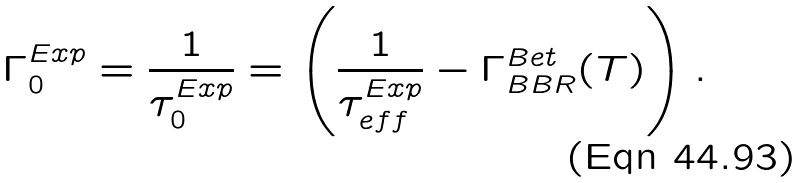Convert formula to latex. <formula><loc_0><loc_0><loc_500><loc_500>\Gamma _ { 0 } ^ { E x p } = \frac { 1 } { \tau _ { 0 } ^ { E x p } } = \left ( \frac { 1 } { \tau _ { e f f } ^ { E x p } } - \Gamma ^ { B e t } _ { B B R } ( T ) \right ) .</formula> 